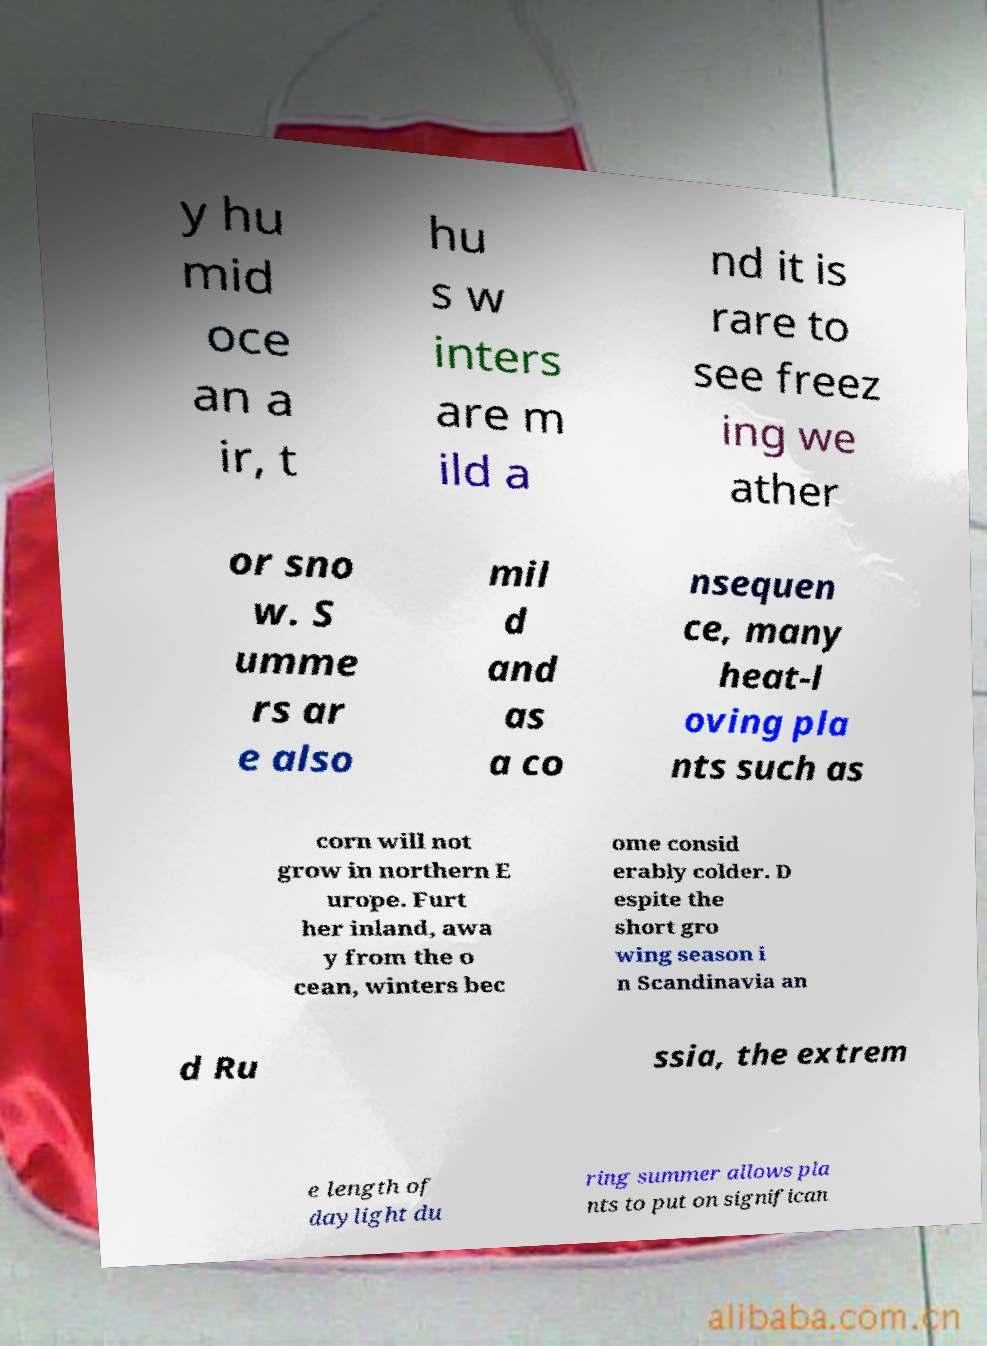Can you read and provide the text displayed in the image?This photo seems to have some interesting text. Can you extract and type it out for me? y hu mid oce an a ir, t hu s w inters are m ild a nd it is rare to see freez ing we ather or sno w. S umme rs ar e also mil d and as a co nsequen ce, many heat-l oving pla nts such as corn will not grow in northern E urope. Furt her inland, awa y from the o cean, winters bec ome consid erably colder. D espite the short gro wing season i n Scandinavia an d Ru ssia, the extrem e length of daylight du ring summer allows pla nts to put on significan 